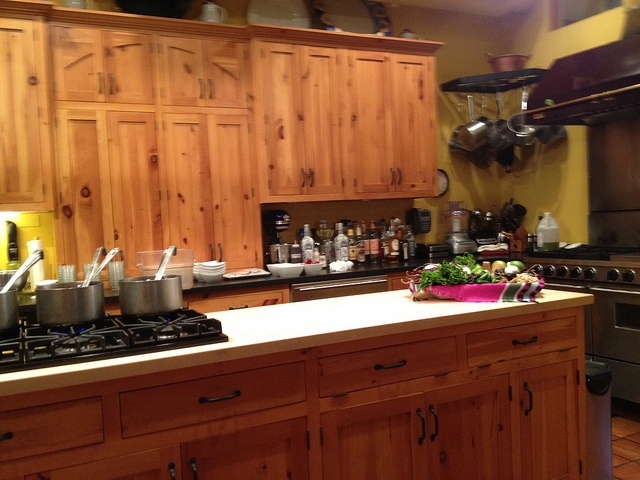Describe the objects in this image and their specific colors. I can see oven in maroon, black, and gray tones, broccoli in maroon, darkgreen, black, and olive tones, bottle in maroon, black, and gray tones, bottle in maroon, gray, darkgray, and black tones, and bottle in maroon, darkgray, and gray tones in this image. 